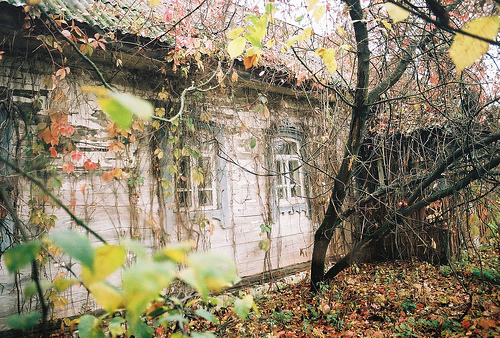<image>
Can you confirm if the window is in front of the tree? Yes. The window is positioned in front of the tree, appearing closer to the camera viewpoint. 